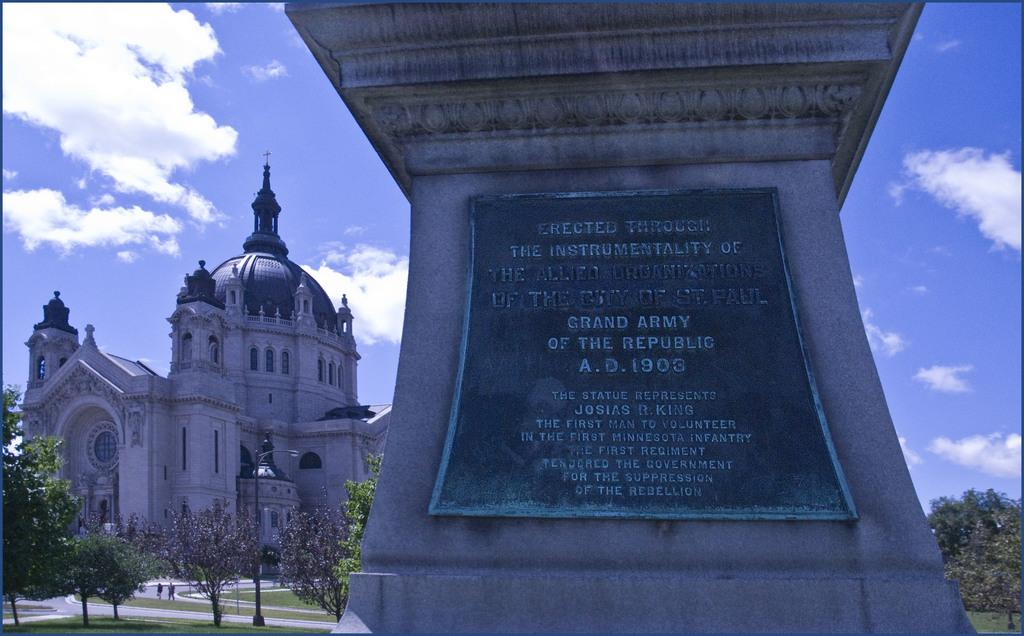What is the main subject of the image? There is a monument in the image. What can be seen around the monument? There are many trees near the monument. What is visible in the background of the image? There is a building in the background of the image. What is the condition of the sky in the image? The sky is visible in the background of the image, and there are clouds present. What type of fruit is hanging from the trees near the monument in the image? There is no fruit visible in the image; only trees are present near the monument. 